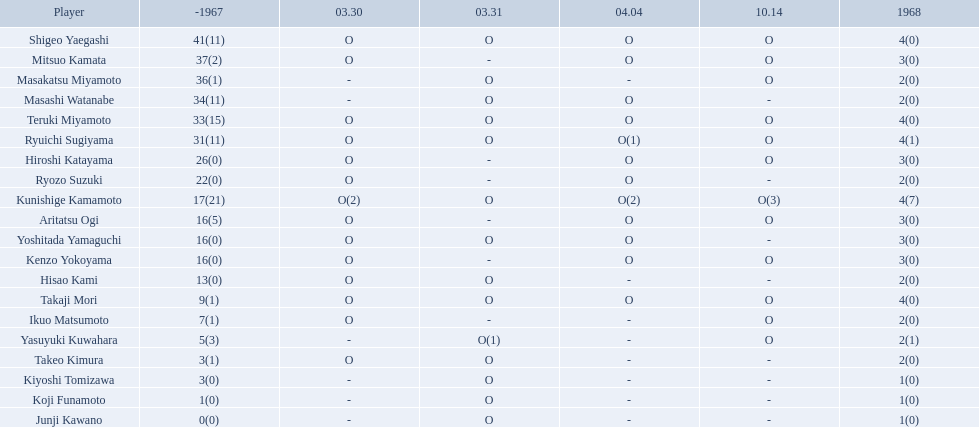How many points did takaji mori have? 13(1). And how many points did junji kawano have? 1(0). To who does the higher of these belong to? Takaji Mori. 